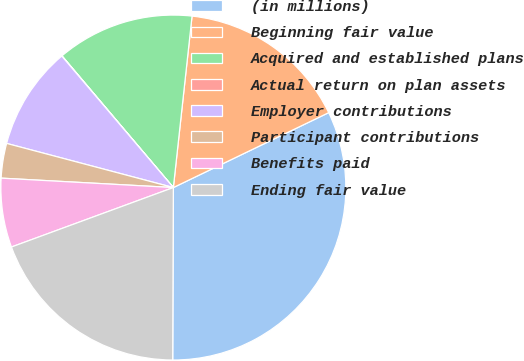<chart> <loc_0><loc_0><loc_500><loc_500><pie_chart><fcel>(in millions)<fcel>Beginning fair value<fcel>Acquired and established plans<fcel>Actual return on plan assets<fcel>Employer contributions<fcel>Participant contributions<fcel>Benefits paid<fcel>Ending fair value<nl><fcel>32.21%<fcel>16.12%<fcel>12.9%<fcel>0.03%<fcel>9.68%<fcel>3.25%<fcel>6.47%<fcel>19.34%<nl></chart> 